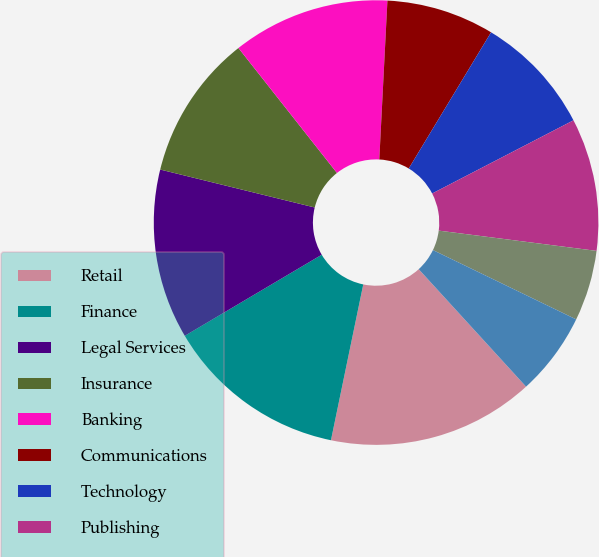Convert chart. <chart><loc_0><loc_0><loc_500><loc_500><pie_chart><fcel>Retail<fcel>Finance<fcel>Legal Services<fcel>Insurance<fcel>Banking<fcel>Communications<fcel>Technology<fcel>Publishing<fcel>Government<fcel>Pharmaceuticals<nl><fcel>15.04%<fcel>13.24%<fcel>12.34%<fcel>10.54%<fcel>11.44%<fcel>7.84%<fcel>8.74%<fcel>9.64%<fcel>5.14%<fcel>6.04%<nl></chart> 